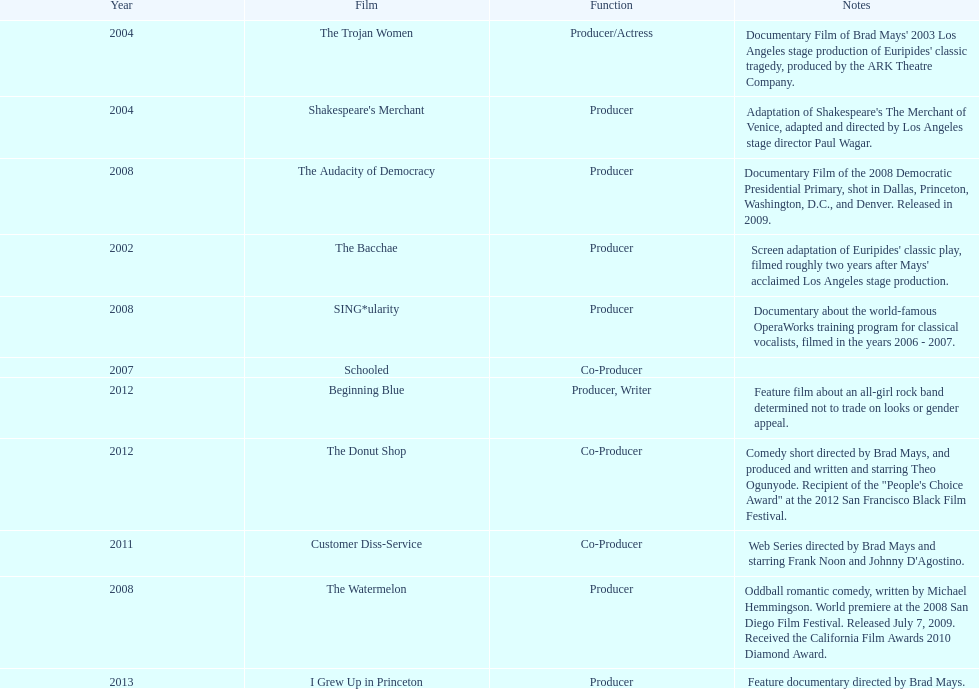In what year were there three or more films? 2008. 